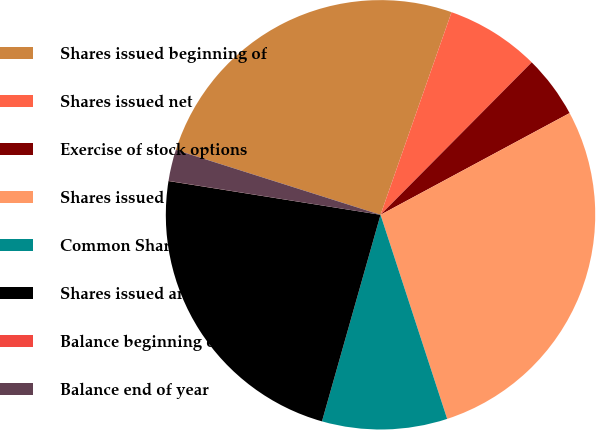<chart> <loc_0><loc_0><loc_500><loc_500><pie_chart><fcel>Shares issued beginning of<fcel>Shares issued net<fcel>Exercise of stock options<fcel>Shares issued end of year<fcel>Common Shares in treasury end<fcel>Shares issued and outstanding<fcel>Balance beginning of year<fcel>Balance end of year<nl><fcel>25.48%<fcel>7.07%<fcel>4.71%<fcel>27.83%<fcel>9.42%<fcel>23.12%<fcel>0.01%<fcel>2.36%<nl></chart> 